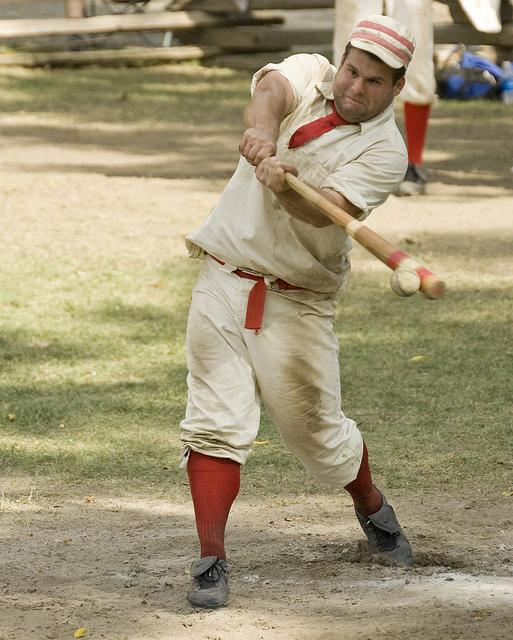Which country headquarters the brand company of this man's shoes? Please explain your reasoning. united states. The united states made the shoes since the man is playing baseball and that is america's sport. 